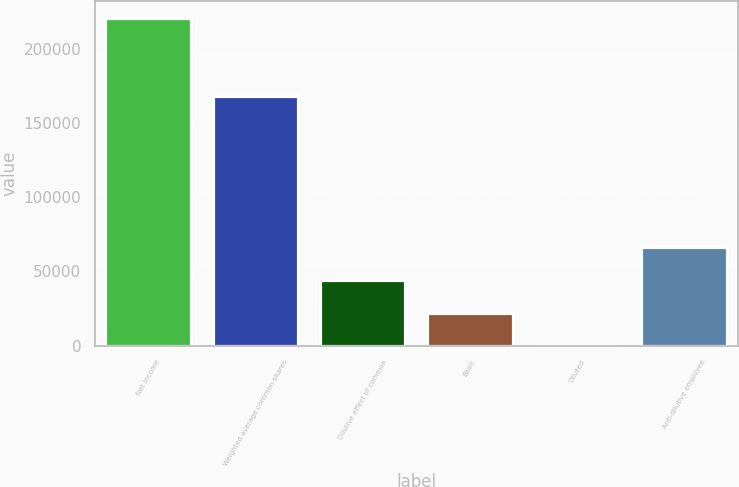Convert chart. <chart><loc_0><loc_0><loc_500><loc_500><bar_chart><fcel>Net income<fcel>Weighted average common shares<fcel>Dilutive effect of common<fcel>Basic<fcel>Diluted<fcel>Anti-dilutive employee<nl><fcel>221364<fcel>168709<fcel>44274<fcel>22137.7<fcel>1.47<fcel>66410.2<nl></chart> 